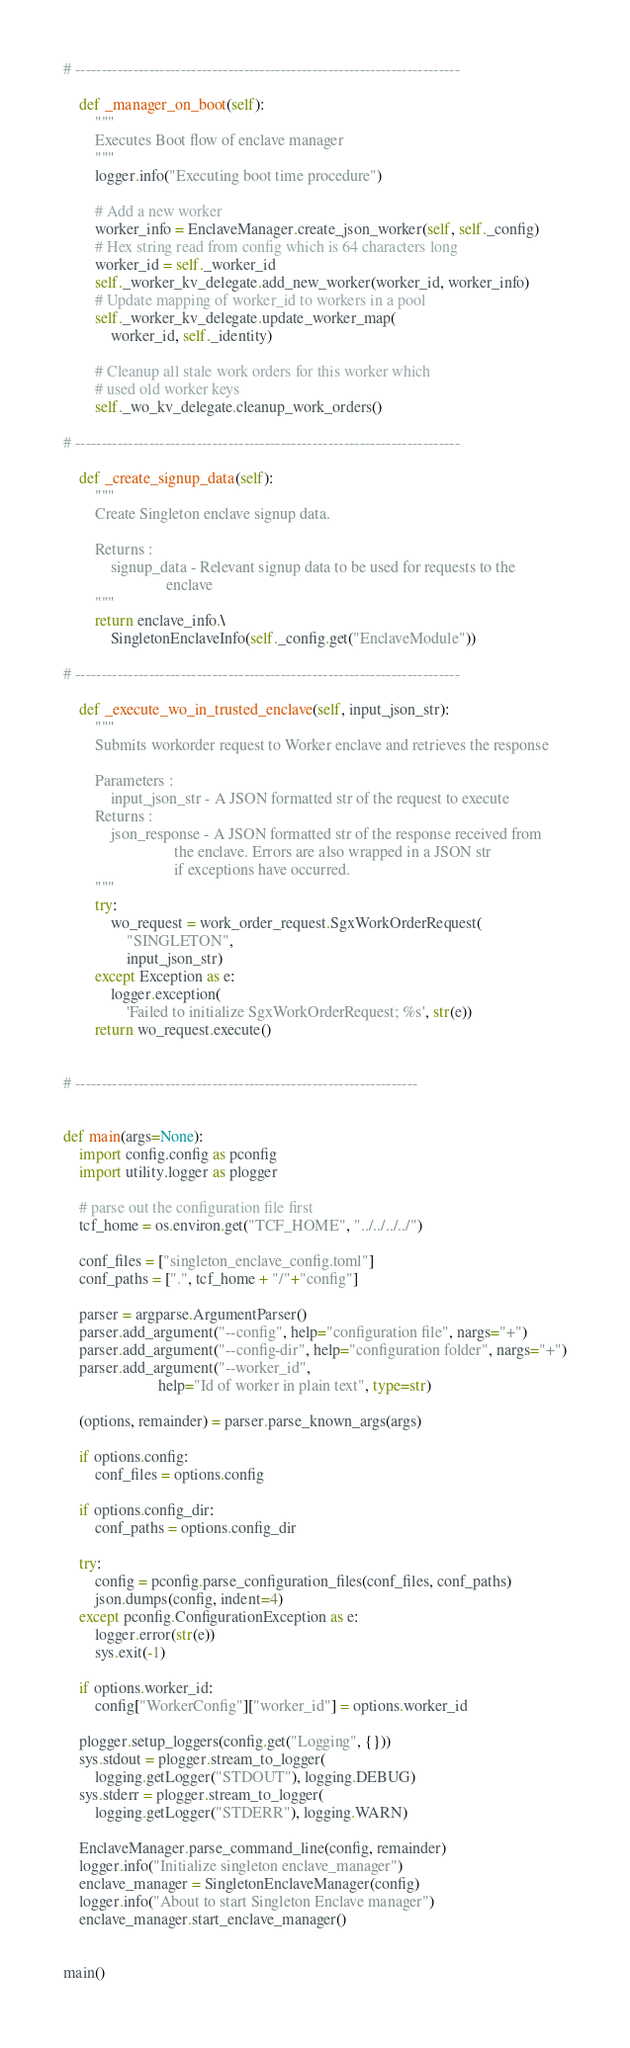<code> <loc_0><loc_0><loc_500><loc_500><_Python_>
# -------------------------------------------------------------------------

    def _manager_on_boot(self):
        """
        Executes Boot flow of enclave manager
        """
        logger.info("Executing boot time procedure")

        # Add a new worker
        worker_info = EnclaveManager.create_json_worker(self, self._config)
        # Hex string read from config which is 64 characters long
        worker_id = self._worker_id
        self._worker_kv_delegate.add_new_worker(worker_id, worker_info)
        # Update mapping of worker_id to workers in a pool
        self._worker_kv_delegate.update_worker_map(
            worker_id, self._identity)

        # Cleanup all stale work orders for this worker which
        # used old worker keys
        self._wo_kv_delegate.cleanup_work_orders()

# -------------------------------------------------------------------------

    def _create_signup_data(self):
        """
        Create Singleton enclave signup data.

        Returns :
            signup_data - Relevant signup data to be used for requests to the
                          enclave
        """
        return enclave_info.\
            SingletonEnclaveInfo(self._config.get("EnclaveModule"))

# -------------------------------------------------------------------------

    def _execute_wo_in_trusted_enclave(self, input_json_str):
        """
        Submits workorder request to Worker enclave and retrieves the response

        Parameters :
            input_json_str - A JSON formatted str of the request to execute
        Returns :
            json_response - A JSON formatted str of the response received from
                            the enclave. Errors are also wrapped in a JSON str
                            if exceptions have occurred.
        """
        try:
            wo_request = work_order_request.SgxWorkOrderRequest(
                "SINGLETON",
                input_json_str)
        except Exception as e:
            logger.exception(
                'Failed to initialize SgxWorkOrderRequest; %s', str(e))
        return wo_request.execute()


# -----------------------------------------------------------------


def main(args=None):
    import config.config as pconfig
    import utility.logger as plogger

    # parse out the configuration file first
    tcf_home = os.environ.get("TCF_HOME", "../../../../")

    conf_files = ["singleton_enclave_config.toml"]
    conf_paths = [".", tcf_home + "/"+"config"]

    parser = argparse.ArgumentParser()
    parser.add_argument("--config", help="configuration file", nargs="+")
    parser.add_argument("--config-dir", help="configuration folder", nargs="+")
    parser.add_argument("--worker_id",
                        help="Id of worker in plain text", type=str)

    (options, remainder) = parser.parse_known_args(args)

    if options.config:
        conf_files = options.config

    if options.config_dir:
        conf_paths = options.config_dir

    try:
        config = pconfig.parse_configuration_files(conf_files, conf_paths)
        json.dumps(config, indent=4)
    except pconfig.ConfigurationException as e:
        logger.error(str(e))
        sys.exit(-1)

    if options.worker_id:
        config["WorkerConfig"]["worker_id"] = options.worker_id

    plogger.setup_loggers(config.get("Logging", {}))
    sys.stdout = plogger.stream_to_logger(
        logging.getLogger("STDOUT"), logging.DEBUG)
    sys.stderr = plogger.stream_to_logger(
        logging.getLogger("STDERR"), logging.WARN)

    EnclaveManager.parse_command_line(config, remainder)
    logger.info("Initialize singleton enclave_manager")
    enclave_manager = SingletonEnclaveManager(config)
    logger.info("About to start Singleton Enclave manager")
    enclave_manager.start_enclave_manager()


main()
</code> 